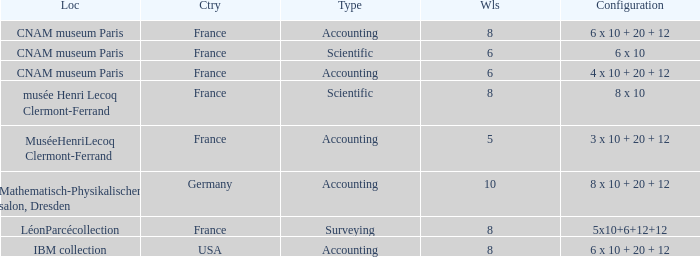What is the configuration for the country France, with accounting as the type, and wheels greater than 6? 6 x 10 + 20 + 12. Help me parse the entirety of this table. {'header': ['Loc', 'Ctry', 'Type', 'Wls', 'Configuration'], 'rows': [['CNAM museum Paris', 'France', 'Accounting', '8', '6 x 10 + 20 + 12'], ['CNAM museum Paris', 'France', 'Scientific', '6', '6 x 10'], ['CNAM museum Paris', 'France', 'Accounting', '6', '4 x 10 + 20 + 12'], ['musée Henri Lecoq Clermont-Ferrand', 'France', 'Scientific', '8', '8 x 10'], ['MuséeHenriLecoq Clermont-Ferrand', 'France', 'Accounting', '5', '3 x 10 + 20 + 12'], ['Mathematisch-Physikalischer salon, Dresden', 'Germany', 'Accounting', '10', '8 x 10 + 20 + 12'], ['LéonParcécollection', 'France', 'Surveying', '8', '5x10+6+12+12'], ['IBM collection', 'USA', 'Accounting', '8', '6 x 10 + 20 + 12']]} 